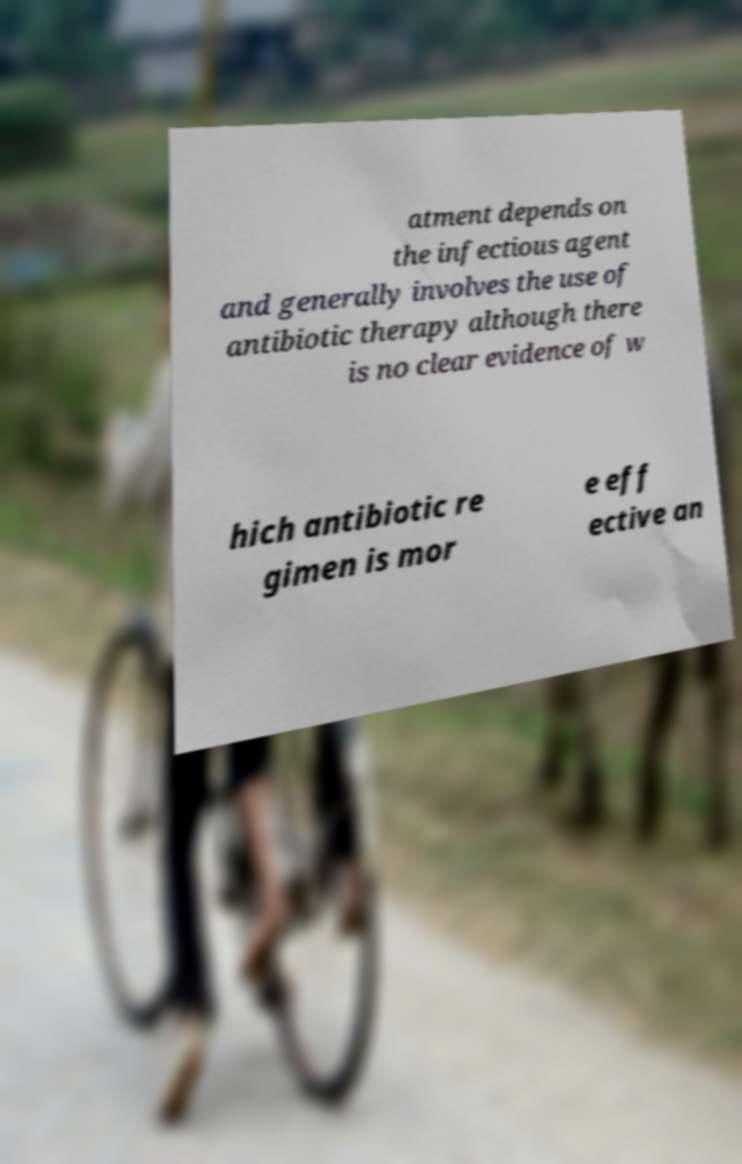Could you assist in decoding the text presented in this image and type it out clearly? atment depends on the infectious agent and generally involves the use of antibiotic therapy although there is no clear evidence of w hich antibiotic re gimen is mor e eff ective an 